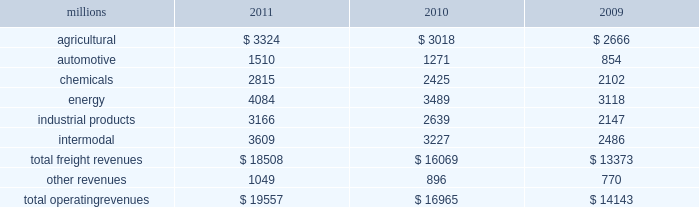Notes to the consolidated financial statements union pacific corporation and subsidiary companies for purposes of this report , unless the context otherwise requires , all references herein to the 201ccorporation 201d , 201cupc 201d , 201cwe 201d , 201cus 201d , and 201cour 201d mean union pacific corporation and its subsidiaries , including union pacific railroad company , which will be separately referred to herein as 201cuprr 201d or the 201crailroad 201d .
Nature of operations operations and segmentation 2013 we are a class i railroad that operates in the u.s .
Our network includes 31898 route miles , linking pacific coast and gulf coast ports with the midwest and eastern u.s .
Gateways and providing several corridors to key mexican gateways .
We own 26027 miles and operate on the remainder pursuant to trackage rights or leases .
We serve the western two-thirds of the country and maintain coordinated schedules with other rail carriers for the handling of freight to and from the atlantic coast , the pacific coast , the southeast , the southwest , canada , and mexico .
Export and import traffic is moved through gulf coast and pacific coast ports and across the mexican and canadian borders .
The railroad , along with its subsidiaries and rail affiliates , is our one reportable operating segment .
Although revenue is analyzed by commodity group , we analyze the net financial results of the railroad as one segment due to the integrated nature of our rail network .
The table provides freight revenue by commodity group : millions 2011 2010 2009 .
Although our revenues are principally derived from customers domiciled in the u.s. , the ultimate points of origination or destination for some products transported by us are outside the u.s .
Basis of presentation 2013 the consolidated financial statements are presented in accordance with accounting principles generally accepted in the u.s .
( gaap ) as codified in the financial accounting standards board ( fasb ) accounting standards codification ( asc ) .
Certain prior year amounts have been disaggregated to provide more detail and conform to the current period financial statement presentation .
Significant accounting policies principles of consolidation 2013 the consolidated financial statements include the accounts of union pacific corporation and all of its subsidiaries .
Investments in affiliated companies ( 20% ( 20 % ) to 50% ( 50 % ) owned ) are accounted for using the equity method of accounting .
All intercompany transactions are eliminated .
We currently have no less than majority-owned investments that require consolidation under variable interest entity requirements .
Cash and cash equivalents 2013 cash equivalents consist of investments with original maturities of three months or less .
Accounts receivable 2013 accounts receivable includes receivables reduced by an allowance for doubtful accounts .
The allowance is based upon historical losses , credit worthiness of customers , and current economic conditions .
Receivables not expected to be collected in one year and the associated allowances are classified as other assets in our consolidated statements of financial position. .
What percent of total freight revenues was automotive in 2010? 
Computations: (1271 / 16069)
Answer: 0.0791. 